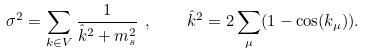<formula> <loc_0><loc_0><loc_500><loc_500>\sigma ^ { 2 } = \sum _ { k \in V } \frac { 1 } { \hat { k } ^ { 2 } + m _ { s } ^ { 2 } } \ , \quad \hat { k } ^ { 2 } = 2 \sum _ { \mu } ( 1 - \cos ( k _ { \mu } ) ) .</formula> 